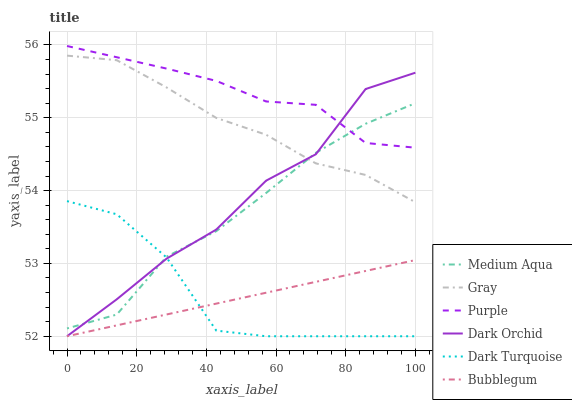Does Dark Turquoise have the minimum area under the curve?
Answer yes or no. No. Does Dark Turquoise have the maximum area under the curve?
Answer yes or no. No. Is Purple the smoothest?
Answer yes or no. No. Is Purple the roughest?
Answer yes or no. No. Does Purple have the lowest value?
Answer yes or no. No. Does Dark Turquoise have the highest value?
Answer yes or no. No. Is Dark Turquoise less than Purple?
Answer yes or no. Yes. Is Gray greater than Bubblegum?
Answer yes or no. Yes. Does Dark Turquoise intersect Purple?
Answer yes or no. No. 